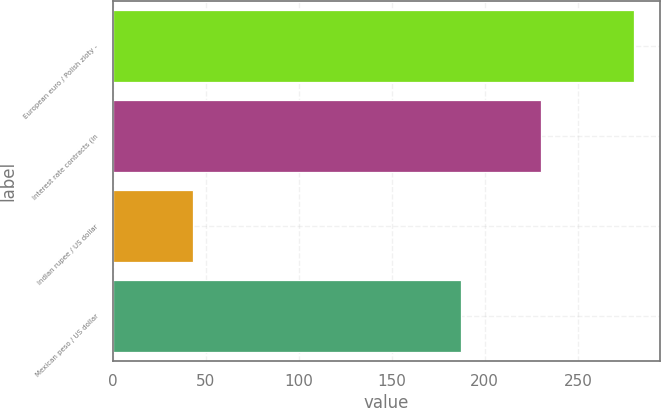Convert chart. <chart><loc_0><loc_0><loc_500><loc_500><bar_chart><fcel>European euro / Polish zloty -<fcel>Interest rate contracts (in<fcel>Indian rupee / US dollar<fcel>Mexican peso / US dollar<nl><fcel>280<fcel>230<fcel>43<fcel>187<nl></chart> 